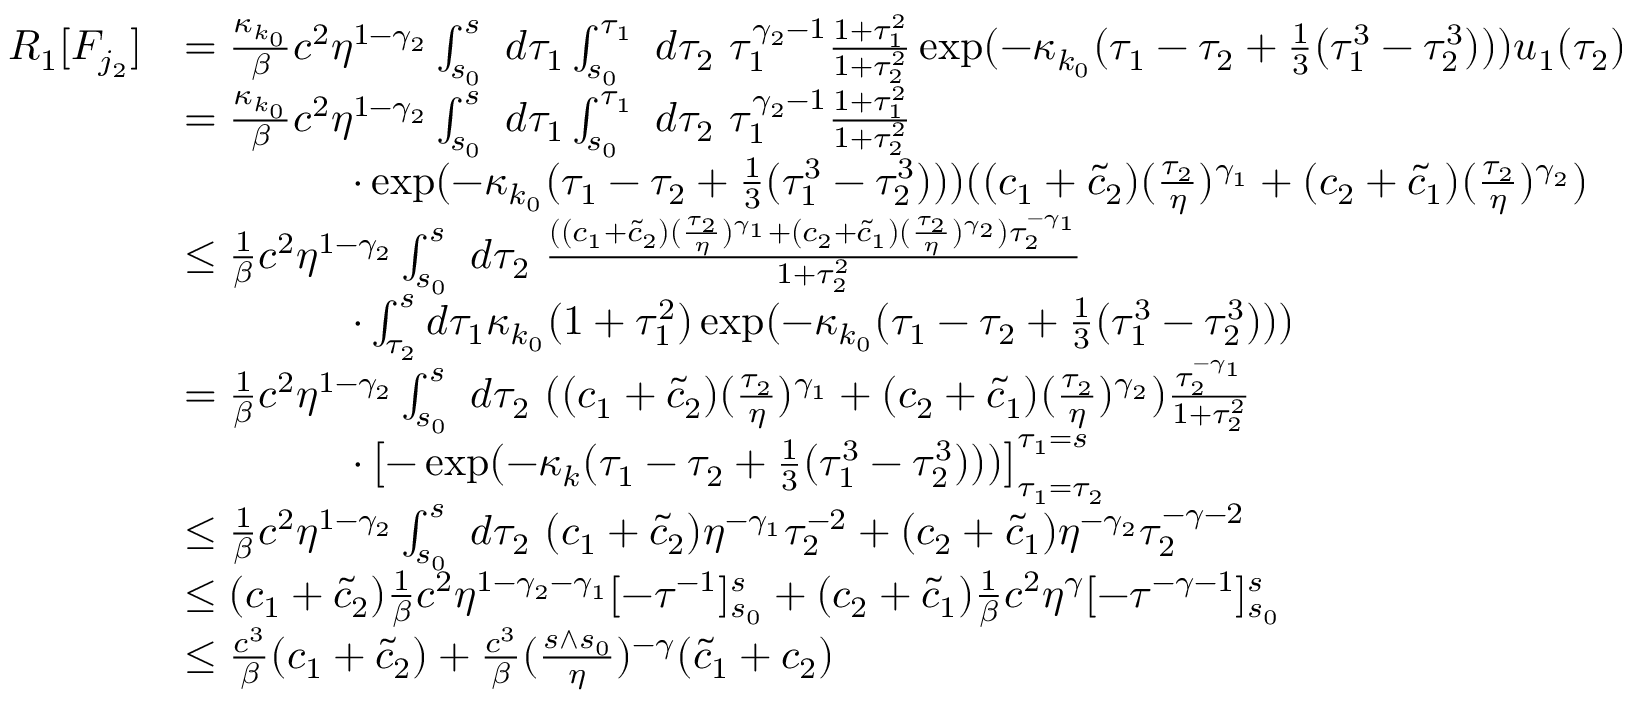Convert formula to latex. <formula><loc_0><loc_0><loc_500><loc_500>\begin{array} { r l } { R _ { 1 } [ F _ { j _ { 2 } } ] } & { = \frac { \kappa _ { k _ { 0 } } } \beta c ^ { 2 } \eta ^ { 1 - \gamma _ { 2 } } \int _ { s _ { 0 } } ^ { s } \ d \tau _ { 1 } \int _ { s _ { 0 } } ^ { \tau _ { 1 } } \ d \tau _ { 2 } \ \tau _ { 1 } ^ { \gamma _ { 2 } - 1 } \frac { 1 + \tau _ { 1 } ^ { 2 } } { 1 + \tau _ { 2 } ^ { 2 } } \exp ( - \kappa _ { k _ { 0 } } ( \tau _ { 1 } - \tau _ { 2 } + \frac { 1 } { 3 } ( \tau _ { 1 } ^ { 3 } - \tau _ { 2 } ^ { 3 } ) ) ) u _ { 1 } ( \tau _ { 2 } ) } \\ & { = \frac { \kappa _ { k _ { 0 } } } \beta c ^ { 2 } \eta ^ { 1 - \gamma _ { 2 } } \int _ { s _ { 0 } } ^ { s } \ d \tau _ { 1 } \int _ { s _ { 0 } } ^ { \tau _ { 1 } } \ d \tau _ { 2 } \ \tau _ { 1 } ^ { \gamma _ { 2 } - 1 } \frac { 1 + \tau _ { 1 } ^ { 2 } } { 1 + \tau _ { 2 } ^ { 2 } } } \\ & { \quad \cdot \exp ( - \kappa _ { k _ { 0 } } ( \tau _ { 1 } - \tau _ { 2 } + \frac { 1 } { 3 } ( \tau _ { 1 } ^ { 3 } - \tau _ { 2 } ^ { 3 } ) ) ) ( ( c _ { 1 } + \tilde { c } _ { 2 } ) ( \frac { \tau _ { 2 } } \eta ) ^ { \gamma _ { 1 } } + ( c _ { 2 } + \tilde { c } _ { 1 } ) ( \frac { \tau _ { 2 } } \eta ) ^ { \gamma _ { 2 } } ) } \\ & { \leq \frac { 1 } \beta c ^ { 2 } \eta ^ { 1 - \gamma _ { 2 } } \int _ { s _ { 0 } } ^ { s } \ d \tau _ { 2 } \ \frac { ( ( c _ { 1 } + \tilde { c } _ { 2 } ) ( \frac { \tau _ { 2 } } \eta ) ^ { \gamma _ { 1 } } + ( c _ { 2 } + \tilde { c } _ { 1 } ) ( \frac { \tau _ { 2 } } \eta ) ^ { \gamma _ { 2 } } ) \tau _ { 2 } ^ { - \gamma _ { 1 } } } { 1 + \tau _ { 2 } ^ { 2 } } \ } \\ & { \quad \cdot \int _ { \tau _ { 2 } } ^ { s } d \tau _ { 1 } \kappa _ { k _ { 0 } } ( 1 + \tau _ { 1 } ^ { 2 } ) \exp ( - \kappa _ { k _ { 0 } } ( \tau _ { 1 } - \tau _ { 2 } + \frac { 1 } { 3 } ( \tau _ { 1 } ^ { 3 } - \tau _ { 2 } ^ { 3 } ) ) ) } \\ & { = \frac { 1 } \beta c ^ { 2 } \eta ^ { 1 - \gamma _ { 2 } } \int _ { s _ { 0 } } ^ { s } \ d \tau _ { 2 } \ ( ( c _ { 1 } + \tilde { c } _ { 2 } ) ( \frac { \tau _ { 2 } } \eta ) ^ { \gamma _ { 1 } } + ( c _ { 2 } + \tilde { c } _ { 1 } ) ( \frac { \tau _ { 2 } } \eta ) ^ { \gamma _ { 2 } } ) \frac { \tau _ { 2 } ^ { - \gamma _ { 1 } } } { 1 + \tau _ { 2 } ^ { 2 } } } \\ & { \quad \cdot \left [ - \exp ( - \kappa _ { k } ( \tau _ { 1 } - \tau _ { 2 } + \frac { 1 } { 3 } ( \tau _ { 1 } ^ { 3 } - \tau _ { 2 } ^ { 3 } ) ) ) \right ] _ { \tau _ { 1 } = \tau _ { 2 } } ^ { \tau _ { 1 } = s } } \\ & { \leq \frac { 1 } \beta c ^ { 2 } \eta ^ { 1 - \gamma _ { 2 } } \int _ { s _ { 0 } } ^ { s } \ d \tau _ { 2 } \ ( c _ { 1 } + \tilde { c } _ { 2 } ) \eta ^ { - \gamma _ { 1 } } \tau _ { 2 } ^ { - 2 } + ( c _ { 2 } + \tilde { c } _ { 1 } ) \eta ^ { - \gamma _ { 2 } } \tau _ { 2 } ^ { - \gamma - 2 } } \\ & { \leq ( c _ { 1 } + \tilde { c } _ { 2 } ) \frac { 1 } \beta c ^ { 2 } \eta ^ { 1 - \gamma _ { 2 } - \gamma _ { 1 } } [ - \tau ^ { - 1 } ] _ { s _ { 0 } } ^ { s } + ( c _ { 2 } + \tilde { c } _ { 1 } ) \frac { 1 } \beta c ^ { 2 } \eta ^ { \gamma } [ - \tau ^ { - \gamma - 1 } ] _ { s _ { 0 } } ^ { s } } \\ & { \leq \frac { c ^ { 3 } } \beta ( c _ { 1 } + \tilde { c } _ { 2 } ) + \frac { c ^ { 3 } } \beta ( \frac { s \wedge s _ { 0 } } \eta ) ^ { - \gamma } ( \tilde { c } _ { 1 } + c _ { 2 } ) } \end{array}</formula> 